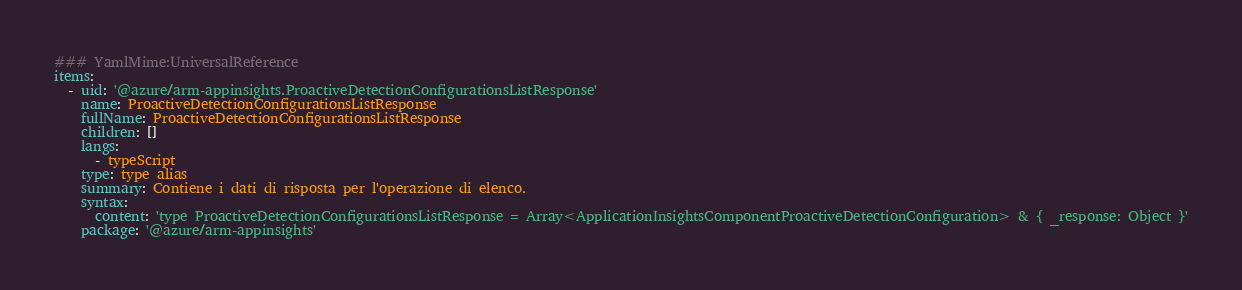Convert code to text. <code><loc_0><loc_0><loc_500><loc_500><_YAML_>### YamlMime:UniversalReference
items:
  - uid: '@azure/arm-appinsights.ProactiveDetectionConfigurationsListResponse'
    name: ProactiveDetectionConfigurationsListResponse
    fullName: ProactiveDetectionConfigurationsListResponse
    children: []
    langs:
      - typeScript
    type: type alias
    summary: Contiene i dati di risposta per l'operazione di elenco.
    syntax:
      content: 'type ProactiveDetectionConfigurationsListResponse = Array<ApplicationInsightsComponentProactiveDetectionConfiguration> & { _response: Object }'
    package: '@azure/arm-appinsights'</code> 